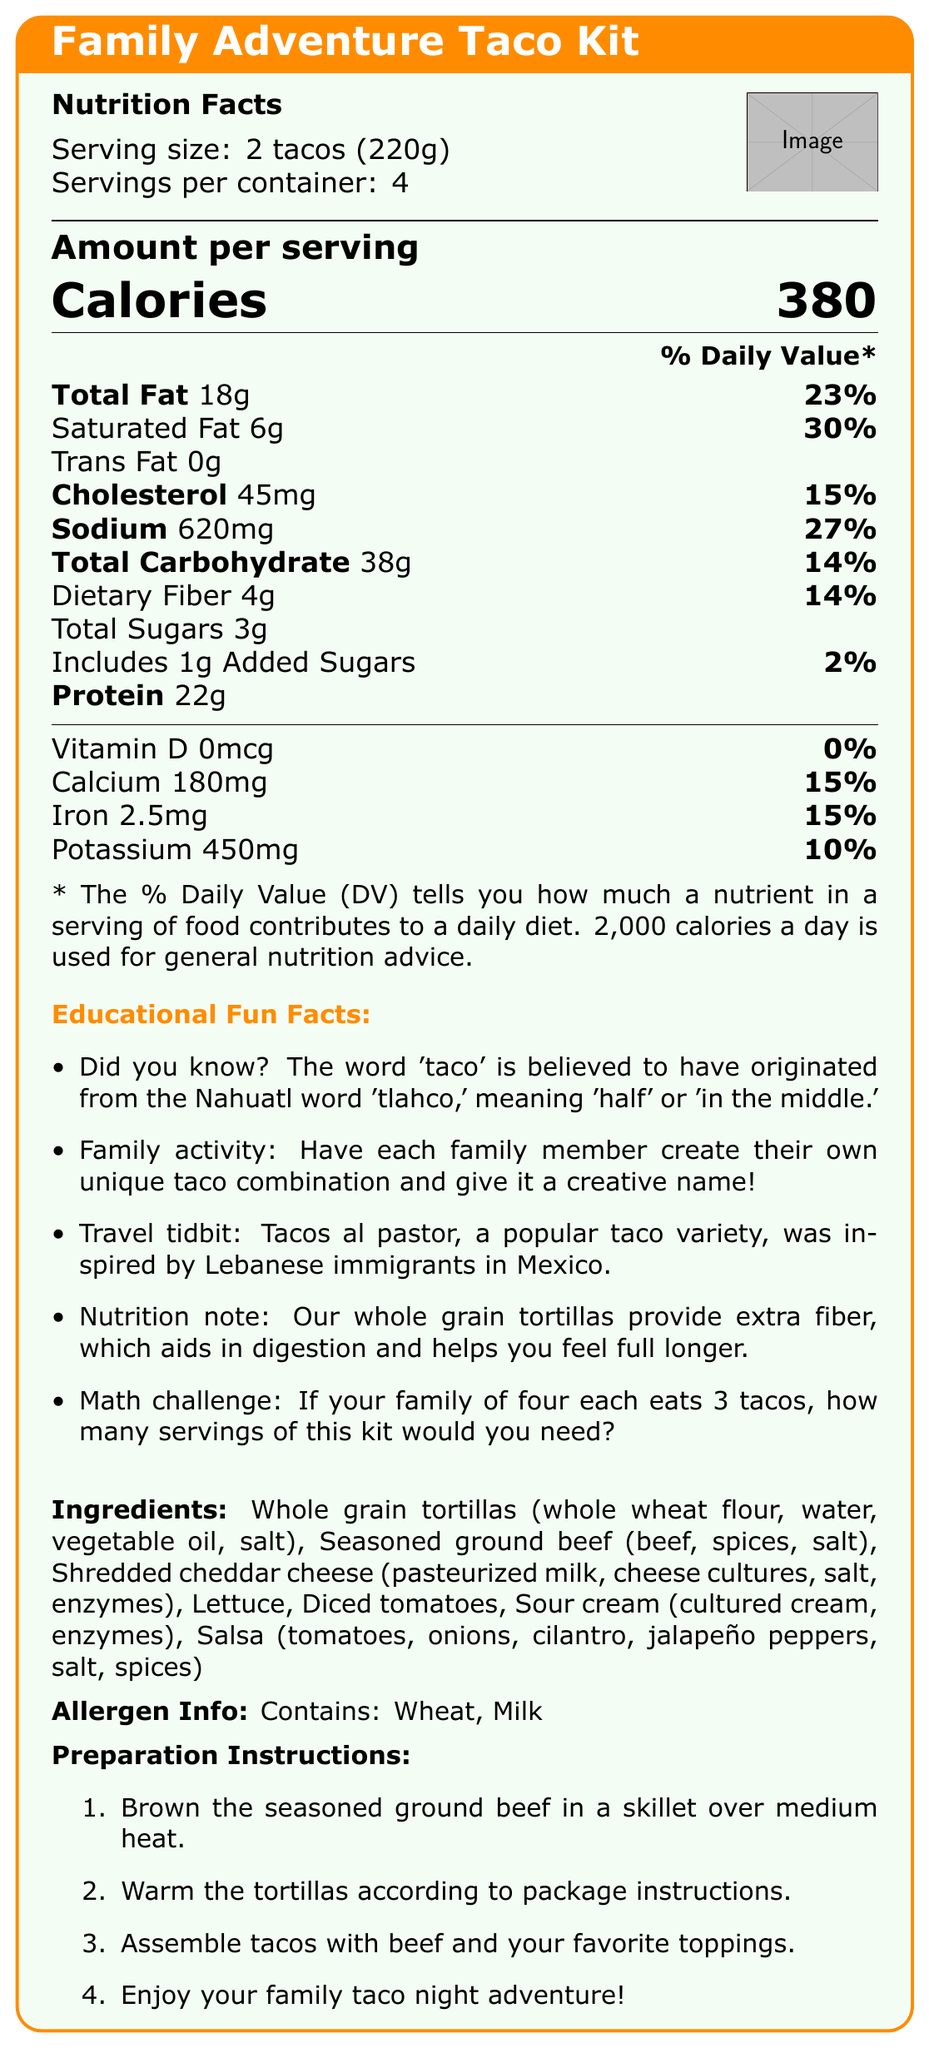what is the serving size for the Family Adventure Taco Kit? The serving size, "2 tacos (220g)," is directly listed in the Nutrition Facts section under the product name.
Answer: 2 tacos (220g) how many servings are there per container? The number of servings per container is listed as "4" in the Nutrition Facts section.
Answer: 4 how many calories are in one serving? The document states that the amount per serving is "Calories 380."
Answer: 380 how much total fat is in a single serving? The Total Fat content per serving is listed as 18g in the Nutrition Facts.
Answer: 18g what percentage of the daily value of calcium does one serving provide? The percentage daily value for calcium is listed as 15% in the vitamins and minerals section of the Nutrition Facts.
Answer: 15% which nutrient contributes the highest % daily value? A. Sodium B. Total Fat C. Iron D. Cholesterol Total Fat contributes 23%, which is the highest, followed by Sodium (27%), Total Fat (23%), and Iron & Calcium (both 15%).
Answer: B which of the following educational fun facts is listed? A. The word 'taco' means 'full' in Nahuatl B. The word 'taco' is inspired by Lebanese immigrants C. Tacos al pastor was inspired by Lebanese immigrants in Mexico D. The word 'taco' is French in origin The document states "Tacos al pastor... was inspired by Lebanese immigrants in Mexico," making "C" the correct option.
Answer: C does the taco kit contain any trans fat? The Nutrition Facts section lists "Trans Fat 0g," indicating no trans fat is present.
Answer: No summarize the main points of the document The document outlines critical nutrition facts, serving sizes, and the health attributes of the meal kit, including educational, fun, and family-oriented activities. Additionally, it lists ingredients, potential allergens, and step-by-step preparation instructions to ensure a delightful family meal experience.
Answer: The Family Adventure Taco Kit document provides nutritional information, serving details, educational fun facts, ingredients, allergen information, and preparation instructions. what is the origin of the word 'taco'? The first educational fun fact states that the word 'taco' originated from the Nahuatl word 'tlahco,' meaning 'half' or 'in the middle.'
Answer: From the Nahuatl word 'tlahco,' meaning 'half' or 'in the middle' how many grams of protein are in a serving? The Nutrition Facts section lists protein content per serving as 22g.
Answer: 22g if your family of four eats 3 tacos each, how many servings of this kit would you need? Each person eats 3 tacos, so 4 people x 3 tacos each = 12 tacos. The kit serving size is 2 tacos, so 12 tacos / 2 tacos per serving = 6 servings. Given the kit serves 4 servings, multiple kits may be required for larger families.
Answer: 6 servings which ingredients contain milk? The ingredient list specifies "Shredded cheddar cheese (pasteurized milk,...)" and "Sour cream (cultured cream,...)," both indicating the presence of milk.
Answer: Shredded cheddar cheese, Sour cream what vitamin is not present in the taco kit? The nutrition facts state that there is 0mcg of Vitamin D per serving, contributing 0% of the daily value.
Answer: Vitamin D how much sodium is there in one serving? The Nutrition Facts show the sodium content per serving as 620mg.
Answer: 620mg is the ingredient list available in the document? The document provides a dedicated section listing all the ingredients required for the Family Adventure Taco Kit.
Answer: Yes where can you find sour cream in the ingredient list? The ingredient list includes sour cream as one of the components, specifically listed as "Sour cream (cultured cream, enzymes)."
Answer: Sour cream (cultured cream, enzymes) what are the preparation instructions for the meal kit? The document outlines four steps under "Preparation Instructions," detailing how to prepare the meal.
Answer: 1. Brown the seasoned ground beef in a skillet over medium heat. 2. Warm the tortillas according to package instructions. 3. Assemble tacos with beef and your favorite toppings. 4. Enjoy your family taco night adventure! what is the percentage of daily value for dietary fiber? The Nutrition Facts section lists the daily value of dietary fiber as 14%.
Answer: 14% how many grams of added sugars are there per serving? The Nutrition Facts section notes that each serving includes 1g of added sugars.
Answer: 1g what is the total amount of carbohydrates per serving? The Nutrition Facts lists the Total Carbohydrate content per serving as 38g.
Answer: 38g how much iron is in one serving? The Nutrition Facts state that the amount of iron per serving is 2.5mg.
Answer: 2.5mg how much Vitamin D is in one serving? The document states that there is 0mcg of Vitamin D per serving.
Answer: 0mcg what is the vegetable oil used in the tortillas? The document does not specify the type of vegetable oil used in the whole grain tortillas, only that it contains vegetable oil.
Answer: Not enough information 